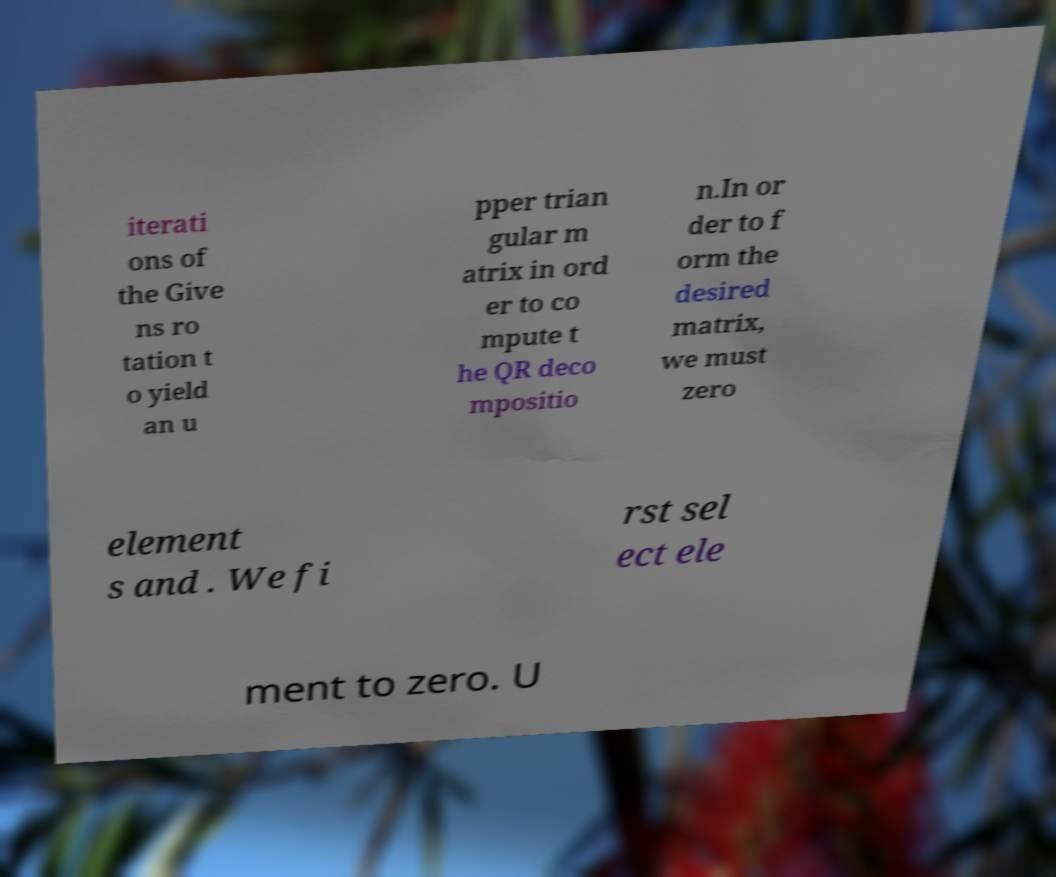What messages or text are displayed in this image? I need them in a readable, typed format. iterati ons of the Give ns ro tation t o yield an u pper trian gular m atrix in ord er to co mpute t he QR deco mpositio n.In or der to f orm the desired matrix, we must zero element s and . We fi rst sel ect ele ment to zero. U 